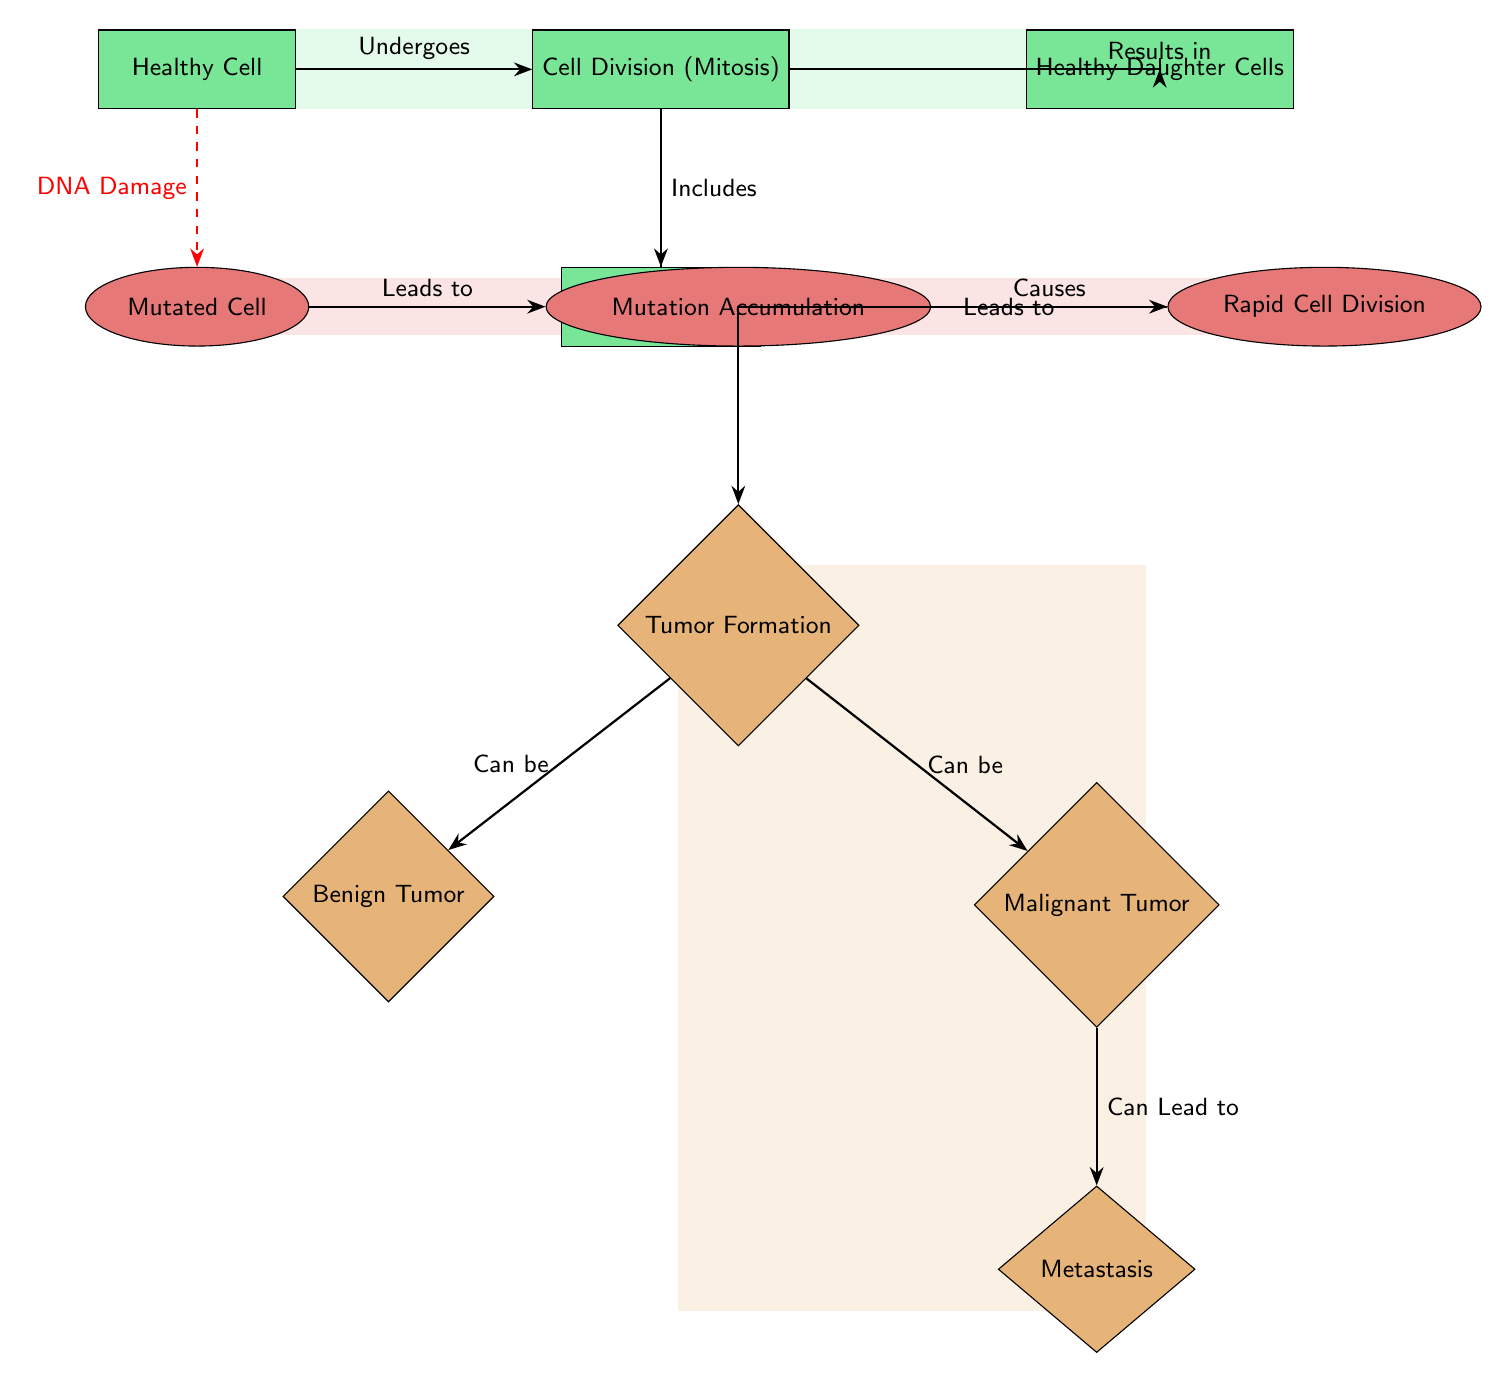What type of cell undergoes division in the diagram? The diagram indicates that the "Healthy Cell" undergoes division, as shown in the first node which is labeled as "Healthy Cell". The arrow pointing to "Cell Division (Mitosis)" confirms that this type of cell can undergo the division process.
Answer: Healthy Cell What is the result of DNA replication in healthy cells? The diagram illustrates that DNA replication occurs under the "Cell Division (Mitosis)" node. Following the flow from "DNA Replication" results in the production of "Healthy Daughter Cells." Therefore, the immediate outcome of DNA replication in healthy cells is these healthy daughter cells.
Answer: Healthy Daughter Cells How many types of tumors are indicated in the diagram? The diagram displays two types of tumors branching from the "Tumor Formation" node: "Benign Tumor" and "Malignant Tumor." Therefore, counting these nodes gives us a total of two distinct tumor types mentioned.
Answer: 2 What leads to rapid cell division from a mutated cell? The diagram indicates that "Mutation Accumulation" is a process that occurs after a cell is identified as a "Mutated Cell." This "Mutation Accumulation" directly causes "Rapid Cell Division." Therefore, the connection between mutation accumulation and rapid division is crucial in this context.
Answer: Mutation Accumulation What happens after tumor formation according to the diagram? The diagram shows that after "Tumor Formation", two pathways lead to different types of tumors: "Benign Tumor" and "Malignant Tumor." The latter then shows a further development labeled "Metastasis." Following this flow indicates that the subsequent outcomes involve either benign or malignant tumor formation and potentially metastasis stemming from malignant tumors.
Answer: Benign Tumor and Malignant Tumor 